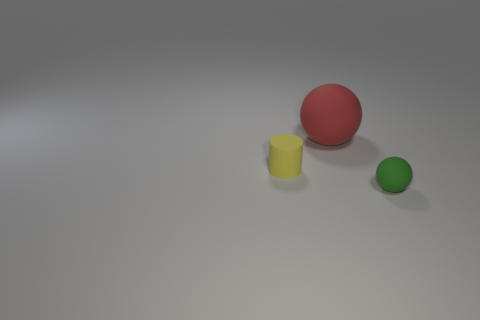Do the big red rubber object and the tiny thing behind the green object have the same shape?
Offer a very short reply. No. Are there more cylinders that are behind the small rubber ball than small gray shiny objects?
Offer a terse response. Yes. Are there fewer small rubber objects on the right side of the cylinder than rubber objects?
Your response must be concise. Yes. How many other spheres have the same color as the large ball?
Give a very brief answer. 0. What is the material of the object that is in front of the big ball and left of the green rubber object?
Your answer should be compact. Rubber. What number of red objects are tiny objects or matte cylinders?
Your answer should be very brief. 0. Is the number of green rubber spheres that are on the right side of the large thing less than the number of spheres to the right of the yellow cylinder?
Your answer should be very brief. Yes. Is there a green thing that has the same size as the cylinder?
Give a very brief answer. Yes. There is a rubber ball that is behind the green matte thing; does it have the same size as the tiny matte sphere?
Give a very brief answer. No. Are there more large red matte balls than large yellow metal cubes?
Your response must be concise. Yes. 